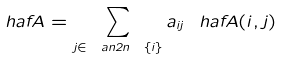<formula> <loc_0><loc_0><loc_500><loc_500>\ h a f A = \sum _ { j \in \ a n { 2 n } \ \{ i \} } a _ { i j } \ h a f A ( i , j )</formula> 